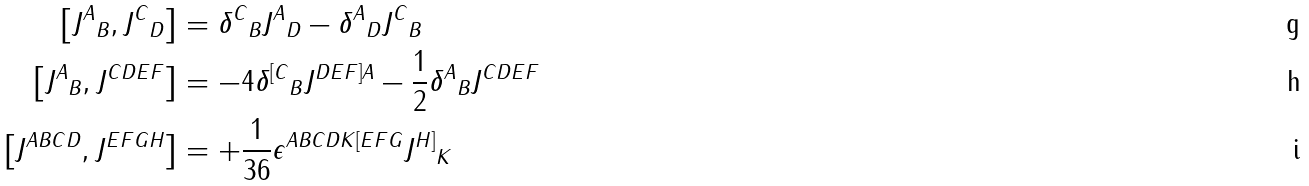<formula> <loc_0><loc_0><loc_500><loc_500>\left [ { J ^ { A } } _ { B } , { J ^ { C } } _ { D } \right ] & = { \delta ^ { C } } _ { B } { J ^ { A } } _ { D } - { \delta ^ { A } } _ { D } { J ^ { C } } _ { B } \\ \left [ { J ^ { A } } _ { B } , J ^ { C D E F } \right ] & = - 4 { \delta ^ { [ C } } _ { B } J ^ { D E F ] A } - \frac { 1 } { 2 } { \delta ^ { A } } _ { B } J ^ { C D E F } \\ \left [ J ^ { A B C D } , J ^ { E F G H } \right ] & = + \frac { 1 } { 3 6 } \epsilon ^ { A B C D K [ E F G } { J ^ { H ] } } _ { K }</formula> 